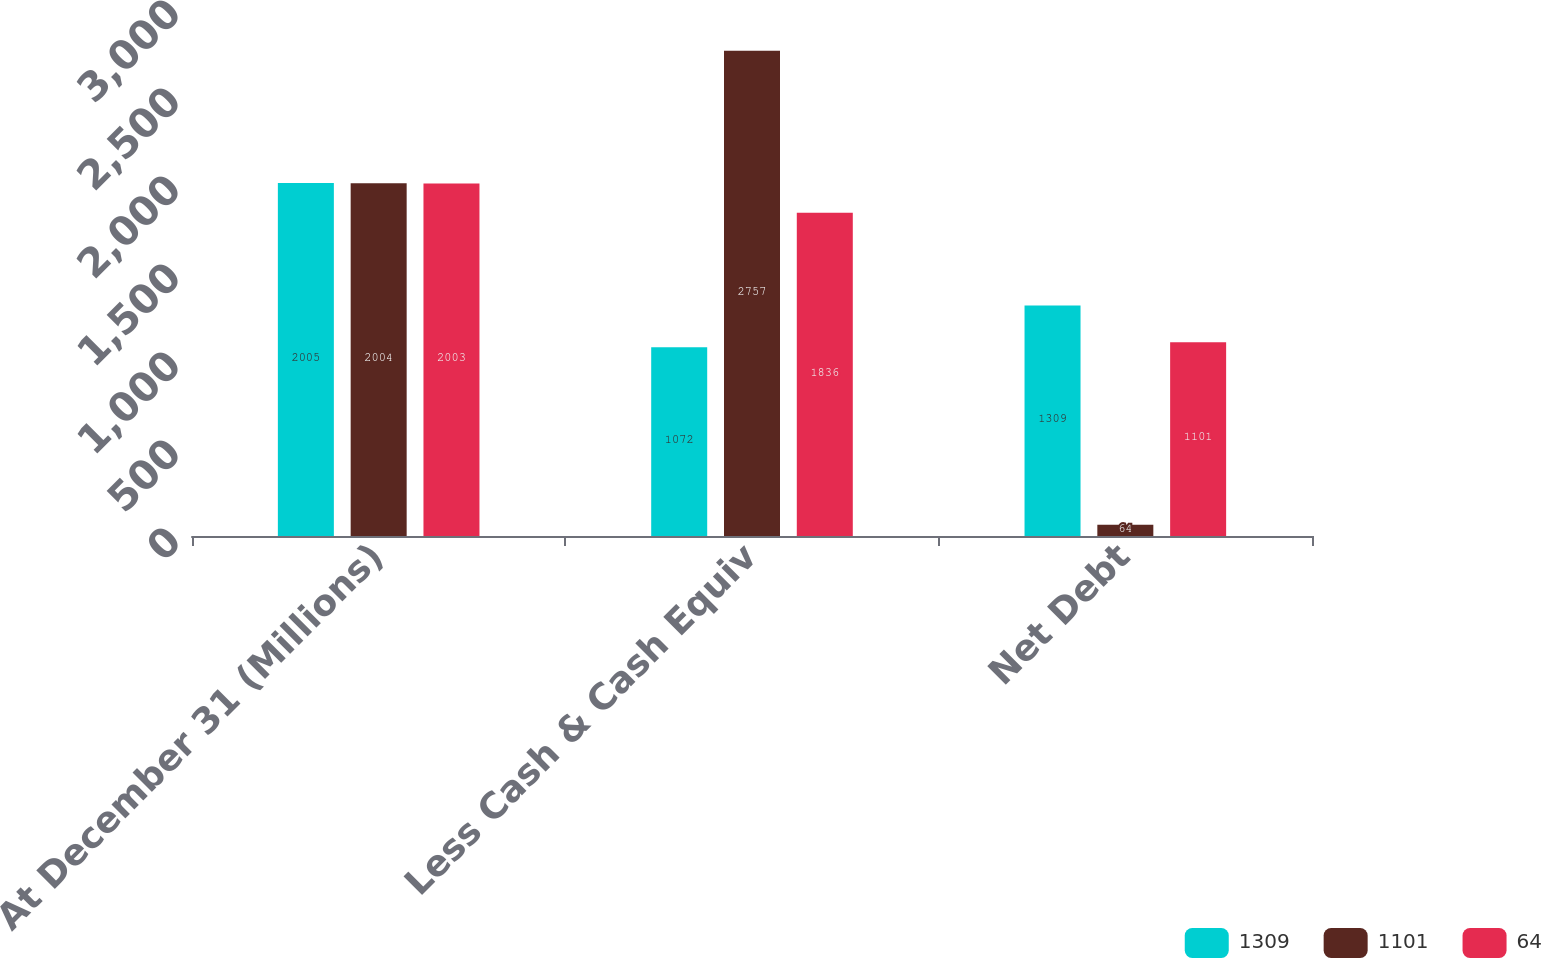<chart> <loc_0><loc_0><loc_500><loc_500><stacked_bar_chart><ecel><fcel>At December 31 (Millions)<fcel>Less Cash & Cash Equiv<fcel>Net Debt<nl><fcel>1309<fcel>2005<fcel>1072<fcel>1309<nl><fcel>1101<fcel>2004<fcel>2757<fcel>64<nl><fcel>64<fcel>2003<fcel>1836<fcel>1101<nl></chart> 